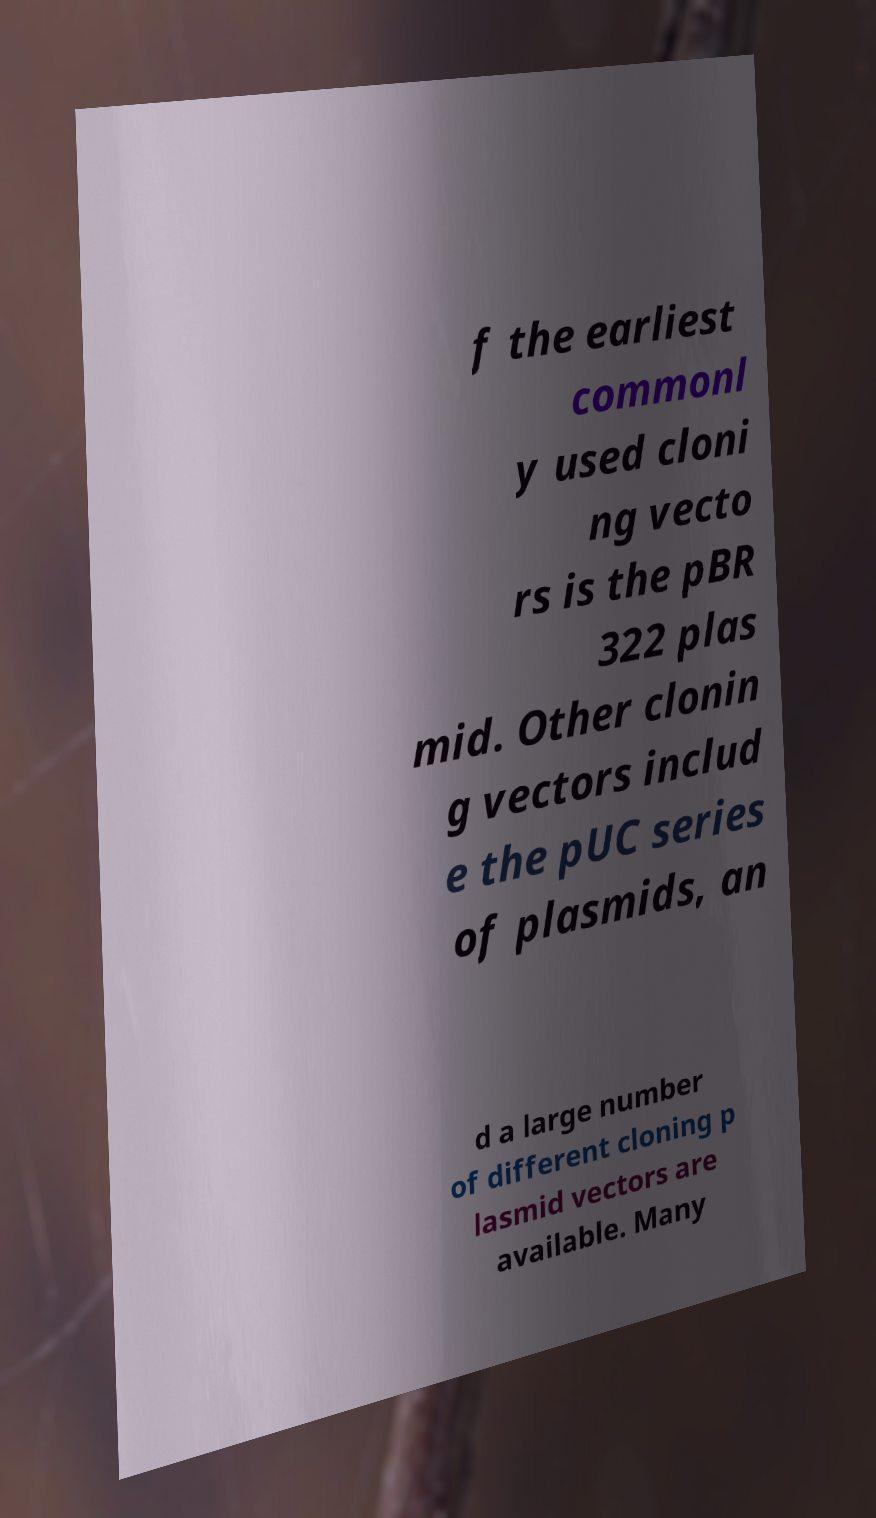Can you read and provide the text displayed in the image?This photo seems to have some interesting text. Can you extract and type it out for me? f the earliest commonl y used cloni ng vecto rs is the pBR 322 plas mid. Other clonin g vectors includ e the pUC series of plasmids, an d a large number of different cloning p lasmid vectors are available. Many 